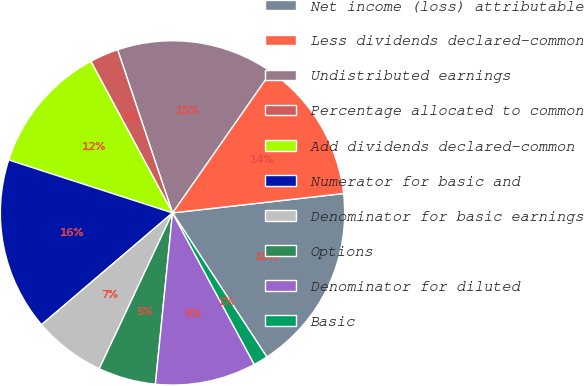<chart> <loc_0><loc_0><loc_500><loc_500><pie_chart><fcel>Net income (loss) attributable<fcel>Less dividends declared-common<fcel>Undistributed earnings<fcel>Percentage allocated to common<fcel>Add dividends declared-common<fcel>Numerator for basic and<fcel>Denominator for basic earnings<fcel>Options<fcel>Denominator for diluted<fcel>Basic<nl><fcel>17.57%<fcel>13.51%<fcel>14.86%<fcel>2.7%<fcel>12.16%<fcel>16.22%<fcel>6.76%<fcel>5.41%<fcel>9.46%<fcel>1.35%<nl></chart> 